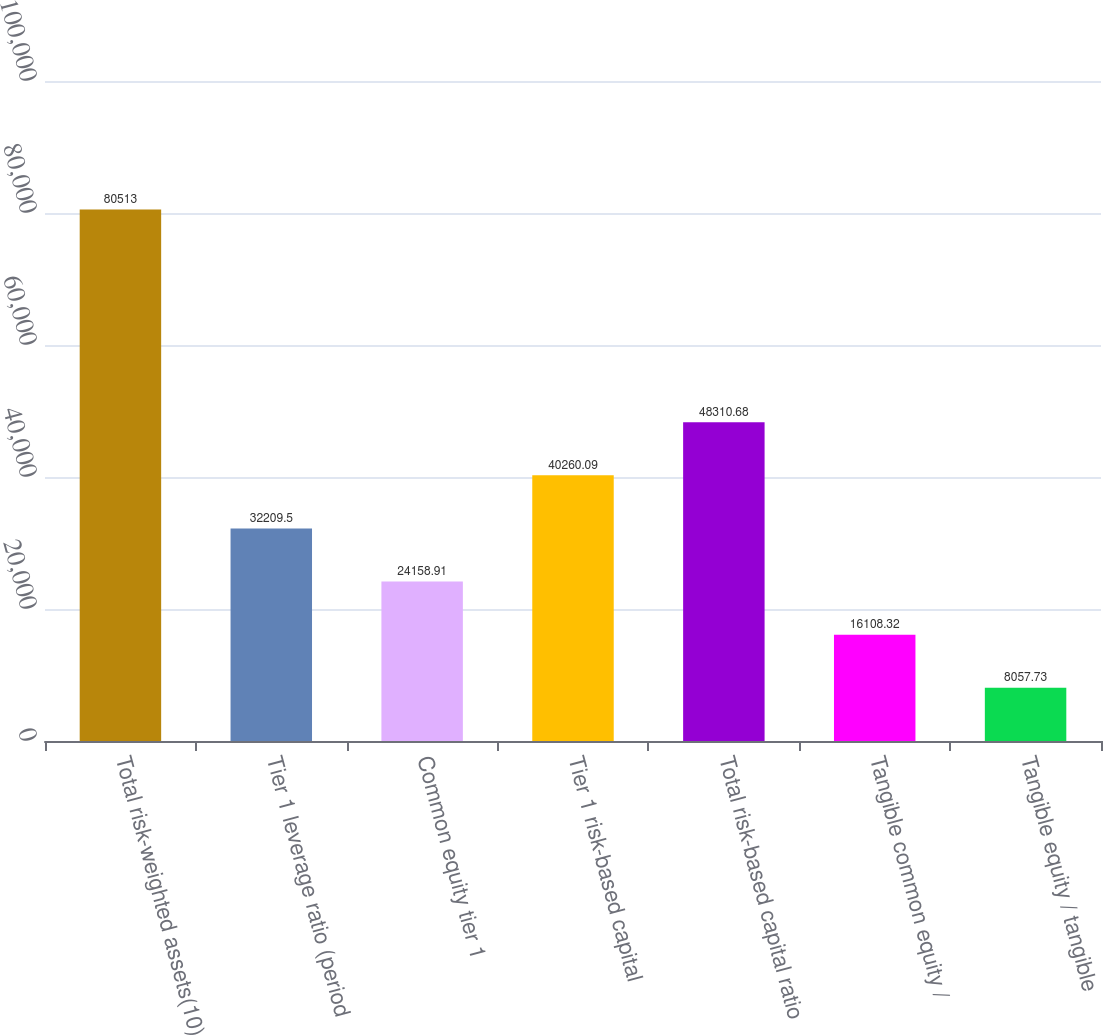<chart> <loc_0><loc_0><loc_500><loc_500><bar_chart><fcel>Total risk-weighted assets(10)<fcel>Tier 1 leverage ratio (period<fcel>Common equity tier 1<fcel>Tier 1 risk-based capital<fcel>Total risk-based capital ratio<fcel>Tangible common equity /<fcel>Tangible equity / tangible<nl><fcel>80513<fcel>32209.5<fcel>24158.9<fcel>40260.1<fcel>48310.7<fcel>16108.3<fcel>8057.73<nl></chart> 